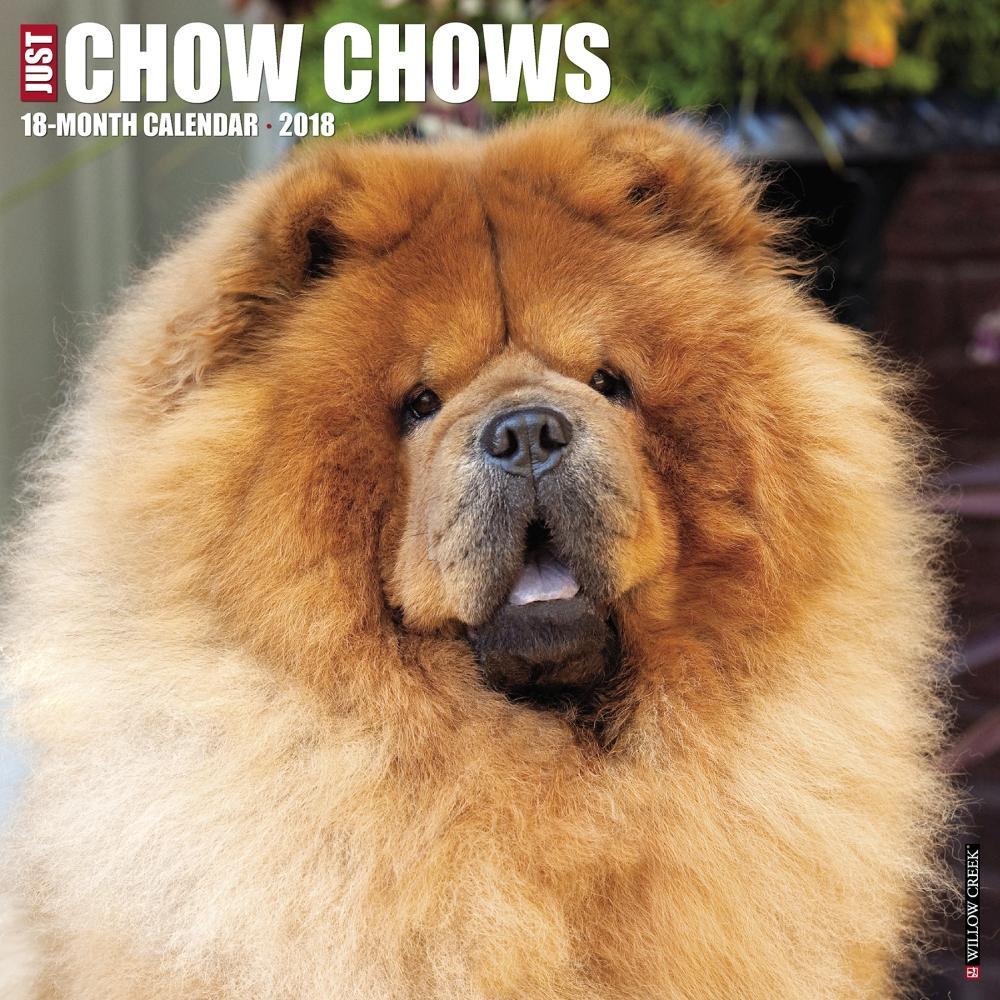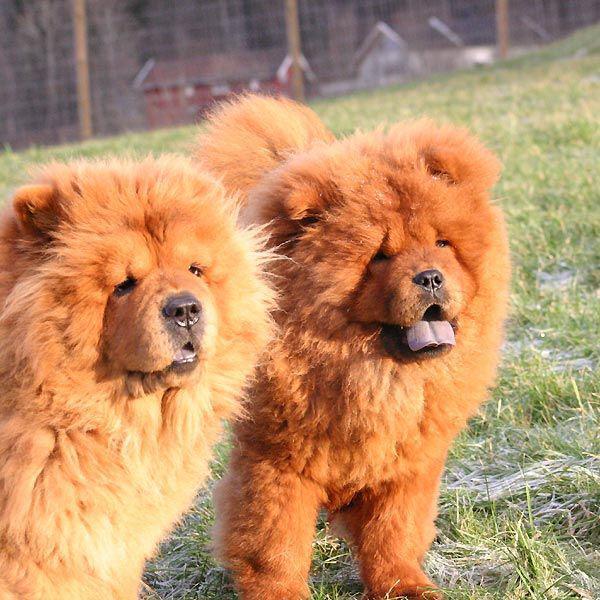The first image is the image on the left, the second image is the image on the right. Considering the images on both sides, is "The left image is a of a single dog standing on grass facing right." valid? Answer yes or no. No. The first image is the image on the left, the second image is the image on the right. For the images shown, is this caption "An image shows only one dog, which is standing on grass and has a closed mouth." true? Answer yes or no. No. 